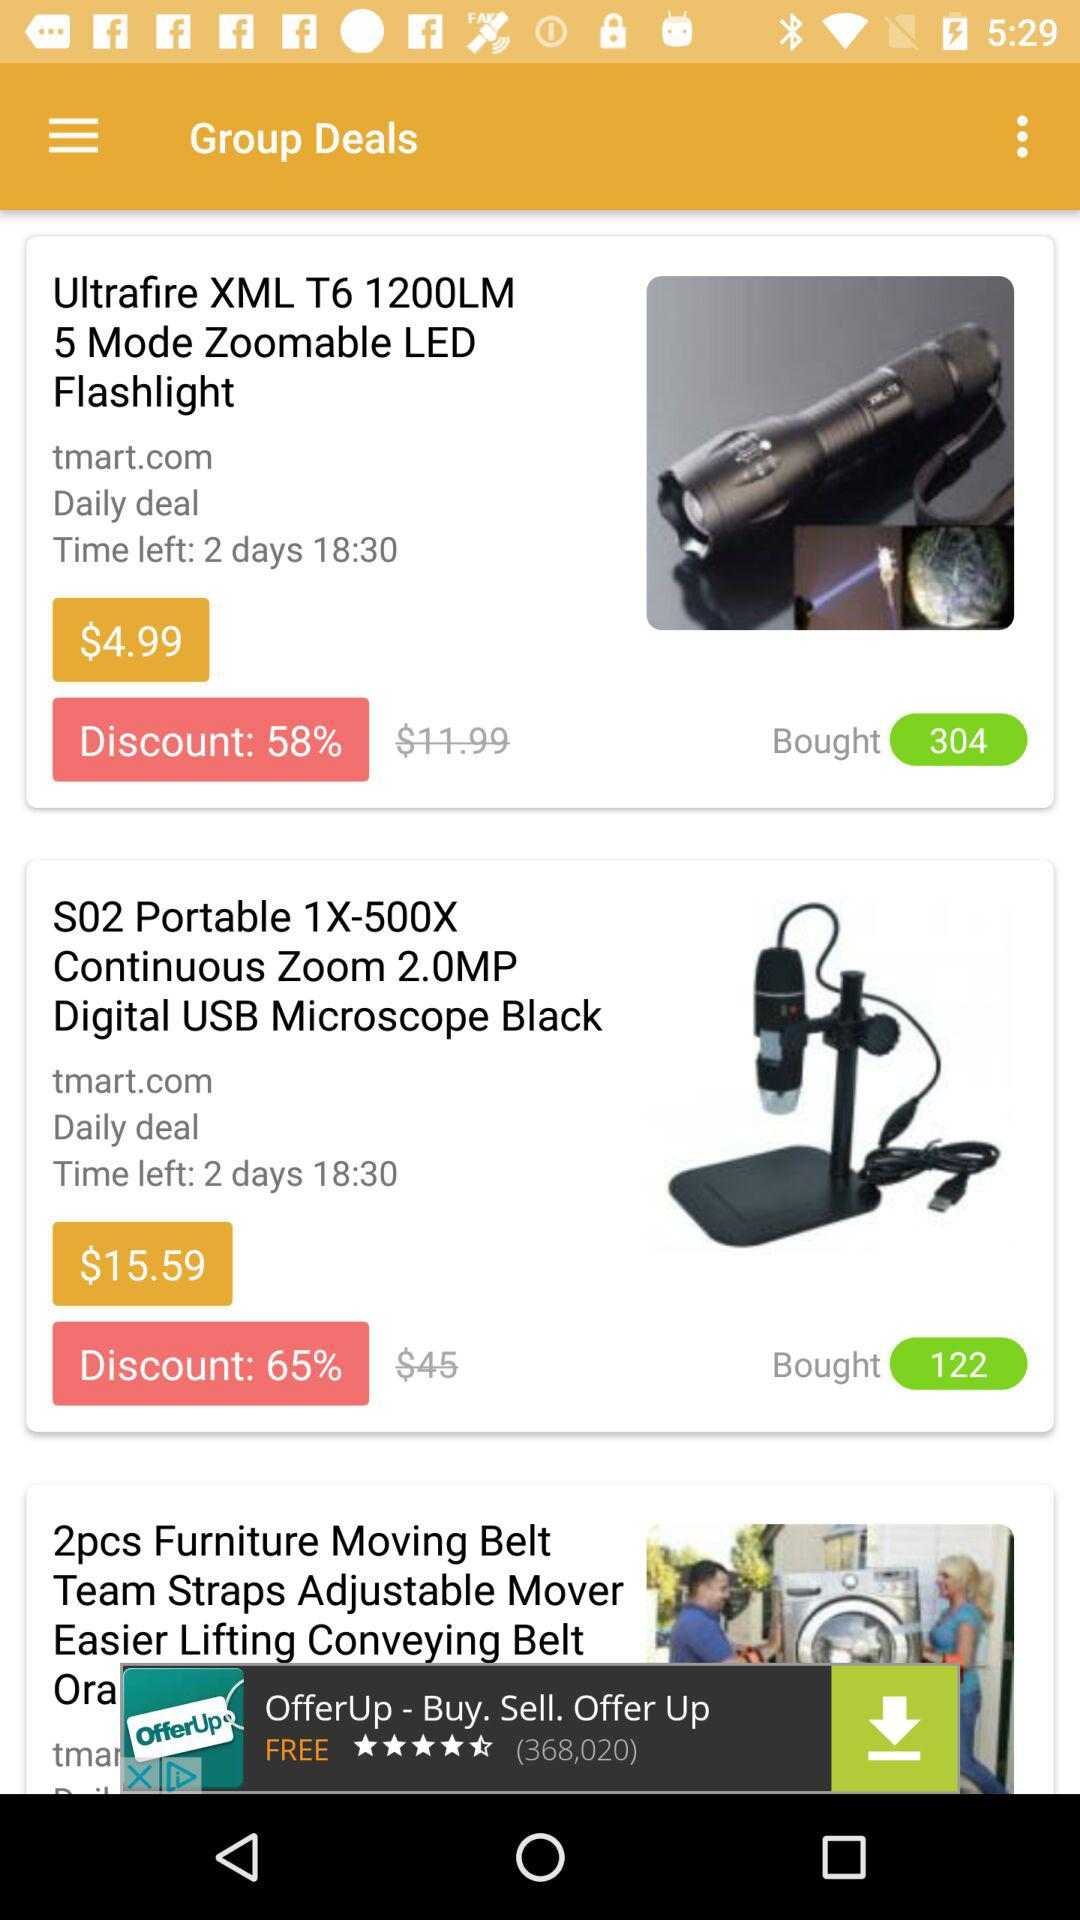How many people have bought "S02 Portable 1X-500X"? There are 122 people who have bought "S02 Portable 1X-500X". 